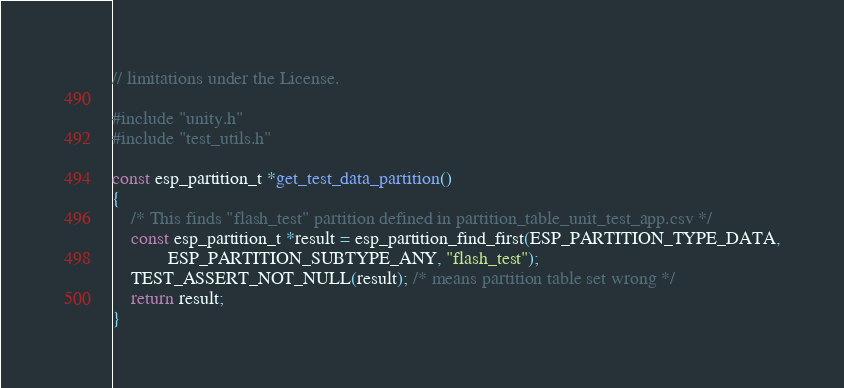<code> <loc_0><loc_0><loc_500><loc_500><_C_>// limitations under the License.

#include "unity.h"
#include "test_utils.h"

const esp_partition_t *get_test_data_partition()
{
    /* This finds "flash_test" partition defined in partition_table_unit_test_app.csv */
    const esp_partition_t *result = esp_partition_find_first(ESP_PARTITION_TYPE_DATA,
            ESP_PARTITION_SUBTYPE_ANY, "flash_test");
    TEST_ASSERT_NOT_NULL(result); /* means partition table set wrong */
    return result;
}
</code> 